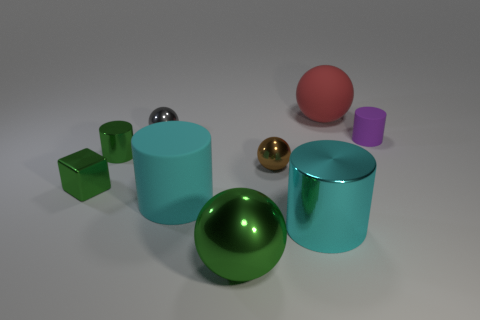What number of objects are big cyan matte things or big rubber objects that are in front of the gray sphere?
Give a very brief answer. 1. What color is the block that is to the left of the cylinder that is in front of the rubber thing in front of the green cylinder?
Your answer should be very brief. Green. There is a rubber cylinder in front of the tiny purple rubber cylinder; how big is it?
Your response must be concise. Large. How many tiny objects are gray objects or matte cylinders?
Ensure brevity in your answer.  2. What color is the metallic object that is both behind the big rubber cylinder and in front of the brown sphere?
Keep it short and to the point. Green. Are there any large shiny things of the same shape as the tiny brown metal object?
Your answer should be very brief. Yes. What is the tiny purple cylinder made of?
Your answer should be very brief. Rubber. Are there any big matte things left of the cyan shiny cylinder?
Offer a very short reply. Yes. Is the shape of the large green shiny object the same as the cyan shiny thing?
Offer a terse response. No. What number of other things are the same size as the green cube?
Keep it short and to the point. 4. 